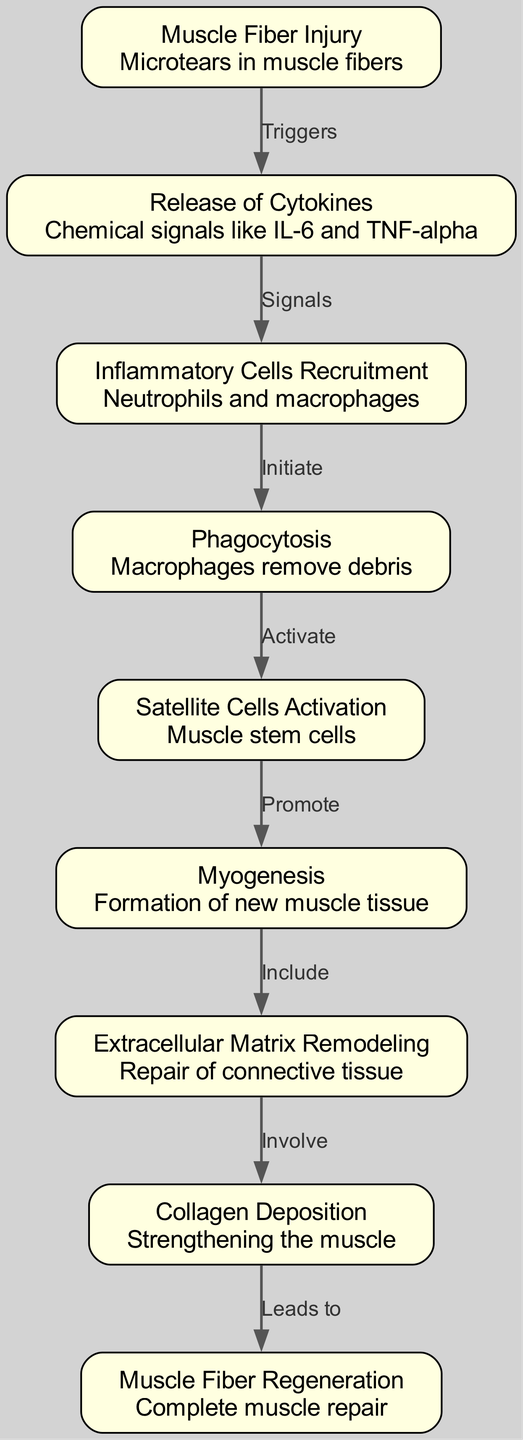What triggers the muscle recovery process in boxers? The muscle recovery process is triggered by muscle fiber injury, which is represented as the starting point ("Muscle Fiber Injury") in the diagram.
Answer: Muscle Fiber Injury How many nodes are there in the diagram? Upon counting the nodes represented in the diagram, we find that there are a total of nine distinct nodes that depict different stages of the muscle recovery process.
Answer: 9 What is the first chemical signal released following muscle fiber injury? Following the muscle fiber injury, the first chemical signals released are cytokines, specifically IL-6 and TNF-alpha, as detailed in the node "Release of Cytokines."
Answer: Cytokines Which cells are involved in the phagocytosis stage? The phagocytosis stage in muscle recovery involves macrophages, as indicated by the corresponding node ("Phagocytosis") that describes their role in removing debris.
Answer: Macrophages What follows the recruitment of inflammatory cells? The recruitment of inflammatory cells, which refers to neutrophils and macrophages, is followed by the process of phagocytosis to initiate debris removal, as shown in the diagram's connected nodes.
Answer: Phagocytosis How does collagen deposition contribute to muscle recovery? Collagen deposition contributes by strengthening the muscle, which is a critical step following the remodeling of the extracellular matrix, as indicated in the diagram's flow of information.
Answer: Strengthening the muscle What is the final outcome of the muscle recovery process? The final outcome of the muscle recovery process, illustrated at the last node, is the complete regeneration of muscle fibers, detailing the ultimate goal of the recovery sequence.
Answer: Complete muscle repair Which signaling substances recruit inflammatory cells to the site of injury? The signaling substances that recruit inflammatory cells to the site of injury are the cytokines released as a response, which directly lead to the recruitment of neutrophils and macrophages.
Answer: Cytokines 